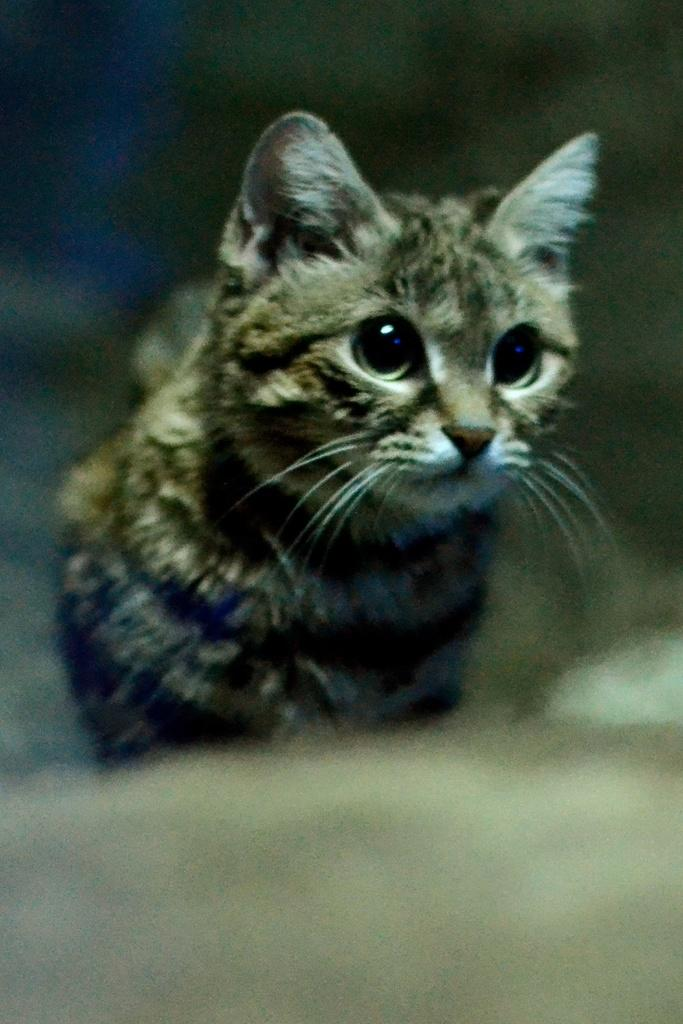What type of animal is present in the image? There is a cat in the image. What time is displayed on the clock in the image? There is no clock present in the image, as the only fact provided is that there is a cat in the image. 